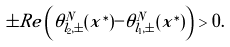Convert formula to latex. <formula><loc_0><loc_0><loc_500><loc_500>\pm R e \left ( \tilde { \theta } _ { l _ { 2 } , \pm } ^ { N } ( x ^ { \ast } ) - \tilde { \theta } _ { l _ { 1 } , \pm } ^ { N } ( x ^ { \ast } ) \right ) > 0 .</formula> 